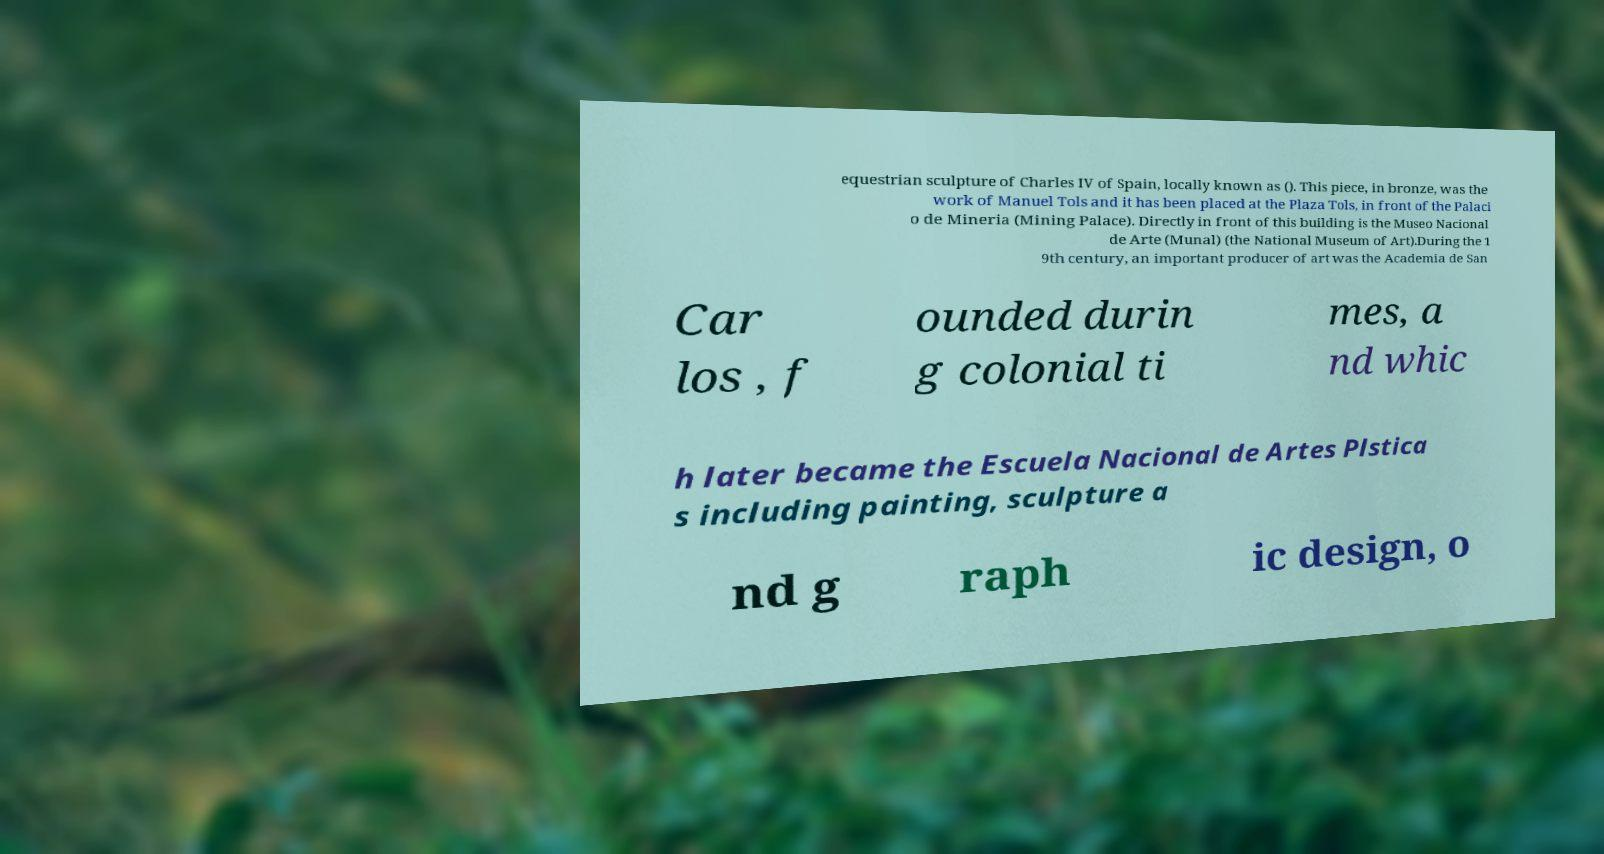For documentation purposes, I need the text within this image transcribed. Could you provide that? equestrian sculpture of Charles IV of Spain, locally known as (). This piece, in bronze, was the work of Manuel Tols and it has been placed at the Plaza Tols, in front of the Palaci o de Mineria (Mining Palace). Directly in front of this building is the Museo Nacional de Arte (Munal) (the National Museum of Art).During the 1 9th century, an important producer of art was the Academia de San Car los , f ounded durin g colonial ti mes, a nd whic h later became the Escuela Nacional de Artes Plstica s including painting, sculpture a nd g raph ic design, o 